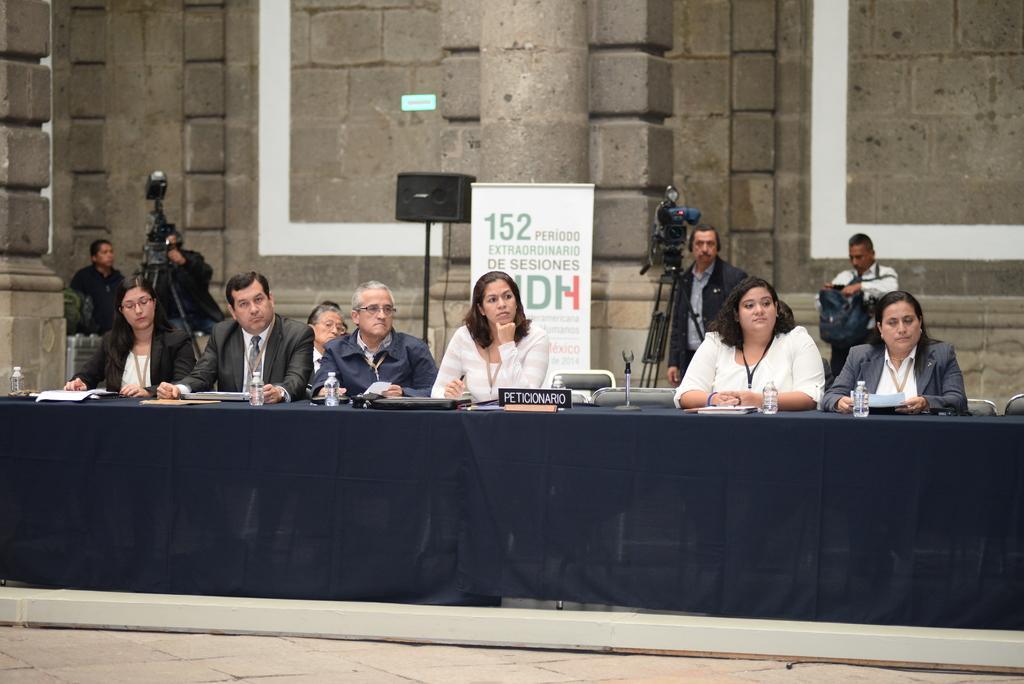In one or two sentences, can you explain what this image depicts? This image is clicked outside. There is a table and there are people sitting in front of that table. That table consists of bottles ,mike's ,papers. Behind them there is a banner and speakers. On the left side there are two people who are holding a camera. On the right side also there are two people who are using camera. Backside there is a building and there is a cloth placed on the table. 